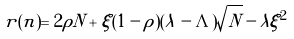Convert formula to latex. <formula><loc_0><loc_0><loc_500><loc_500>r ( n ) = 2 \rho N + \xi ( 1 - \rho ) ( \lambda - \Lambda ) \sqrt { N } - \lambda \xi ^ { 2 }</formula> 